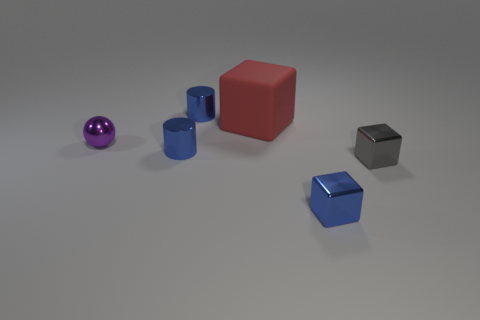Subtract all large red cubes. How many cubes are left? 2 Add 1 blue shiny cylinders. How many objects exist? 7 Subtract all red cubes. How many cubes are left? 2 Subtract all spheres. How many objects are left? 5 Subtract all purple balls. How many purple cylinders are left? 0 Subtract 1 red blocks. How many objects are left? 5 Subtract 1 spheres. How many spheres are left? 0 Subtract all purple blocks. Subtract all green balls. How many blocks are left? 3 Subtract all small shiny cylinders. Subtract all red things. How many objects are left? 3 Add 4 large red rubber blocks. How many large red rubber blocks are left? 5 